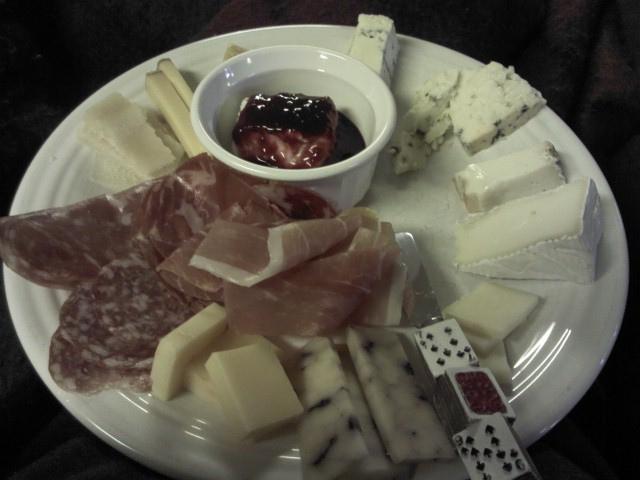What utensil would be most useful in eating these foods?
Answer briefly. Fork. Is there coffee on the plate?
Concise answer only. No. What item is depicted on the plate?
Answer briefly. Meat, cheese. 